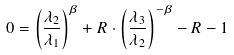Convert formula to latex. <formula><loc_0><loc_0><loc_500><loc_500>0 = \left ( \frac { \lambda _ { 2 } } { \lambda _ { 1 } } \right ) ^ { \beta } + R \cdot \left ( \frac { \lambda _ { 3 } } { \lambda _ { 2 } } \right ) ^ { - \beta } - R - 1</formula> 